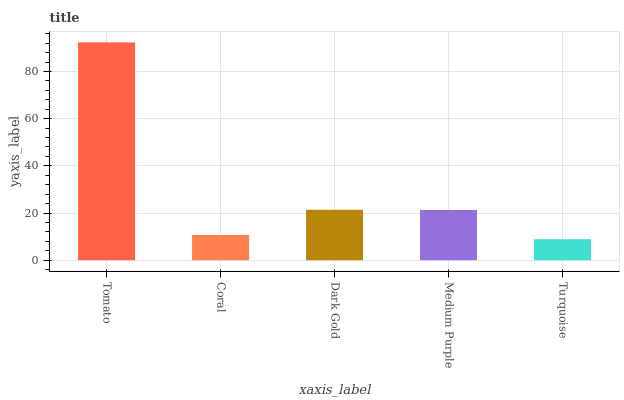Is Turquoise the minimum?
Answer yes or no. Yes. Is Tomato the maximum?
Answer yes or no. Yes. Is Coral the minimum?
Answer yes or no. No. Is Coral the maximum?
Answer yes or no. No. Is Tomato greater than Coral?
Answer yes or no. Yes. Is Coral less than Tomato?
Answer yes or no. Yes. Is Coral greater than Tomato?
Answer yes or no. No. Is Tomato less than Coral?
Answer yes or no. No. Is Medium Purple the high median?
Answer yes or no. Yes. Is Medium Purple the low median?
Answer yes or no. Yes. Is Turquoise the high median?
Answer yes or no. No. Is Turquoise the low median?
Answer yes or no. No. 